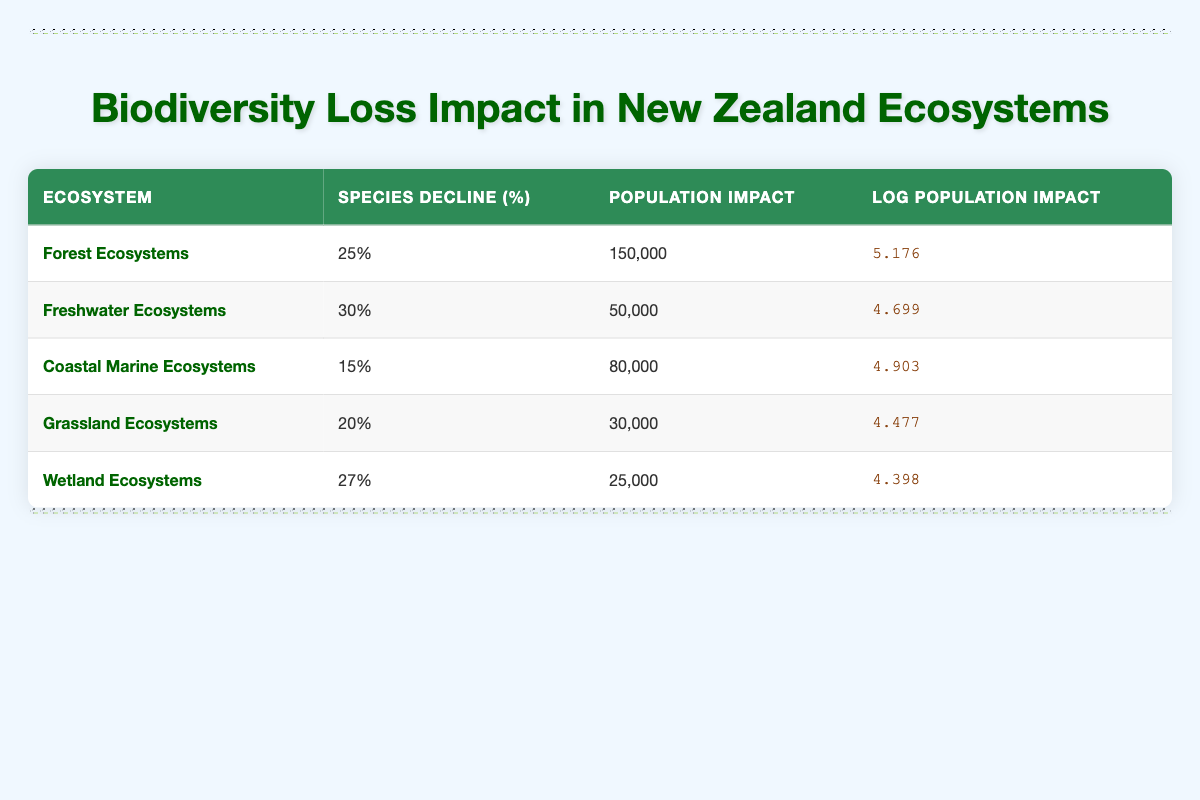What is the population impact of Freshwater Ecosystems? The table shows that the population impact for Freshwater Ecosystems is listed under the "Population Impact" column as 50,000.
Answer: 50,000 Which ecosystem has the highest species decline percentage? To find the ecosystem with the highest species decline percentage, we compare all values in the "Species Decline (%)" column. Freshwater Ecosystems has the highest value at 30%.
Answer: Freshwater Ecosystems What is the average population impact across all ecosystems listed? To calculate the average population impact, first, sum the population impacts: (150,000 + 50,000 + 80,000 + 30,000 + 25,000) = 335,000. There are 5 ecosystems, so the average is 335,000 / 5 = 67,000.
Answer: 67,000 Is the population impact of Coastal Marine Ecosystems greater than that of Grassland Ecosystems? By comparing the two values in the "Population Impact" column, Coastal Marine Ecosystems has a population impact of 80,000 and Grassland Ecosystems has 30,000. Since 80,000 is greater than 30,000, the statement is true.
Answer: Yes What is the total population impact for Forest and Wetland Ecosystems combined? The population impacts for Forest and Wetland Ecosystems are 150,000 and 25,000, respectively. Adding these together gives 150,000 + 25,000 = 175,000 as the total population impact.
Answer: 175,000 Which ecosystem has a log population impact of less than 4.5? Looking at the "Log Population Impact" column, we see that Wetland Ecosystems has a log population impact of 4.398, which is less than 4.5.
Answer: Wetland Ecosystems If the species decline percentage in Grassland Ecosystems increases by 5%, what will be the new percentage? The current species decline percentage for Grassland Ecosystems is 20%. Adding the increase gives 20% + 5% = 25%.
Answer: 25% What percentage of species have declined in Coastal Marine Ecosystems compared to Freshwater Ecosystems? Coastal Marine Ecosystems has a species decline percentage of 15%, while Freshwater Ecosystems has 30%. To find the difference, we calculate 30% - 15% = 15%.
Answer: 15% 